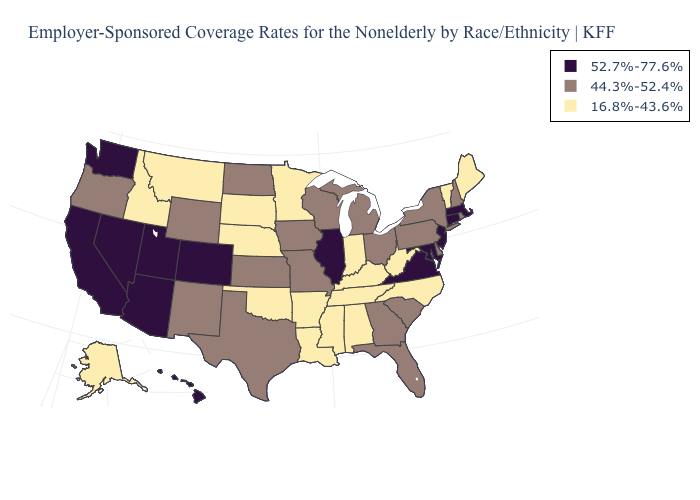What is the highest value in the West ?
Be succinct. 52.7%-77.6%. Does the map have missing data?
Answer briefly. No. What is the value of Iowa?
Answer briefly. 44.3%-52.4%. Among the states that border Iowa , does Nebraska have the lowest value?
Quick response, please. Yes. Among the states that border North Carolina , which have the lowest value?
Give a very brief answer. Tennessee. What is the value of North Carolina?
Keep it brief. 16.8%-43.6%. Does Illinois have the highest value in the USA?
Quick response, please. Yes. What is the value of Nevada?
Quick response, please. 52.7%-77.6%. Name the states that have a value in the range 44.3%-52.4%?
Write a very short answer. Delaware, Florida, Georgia, Iowa, Kansas, Michigan, Missouri, New Hampshire, New Mexico, New York, North Dakota, Ohio, Oregon, Pennsylvania, Rhode Island, South Carolina, Texas, Wisconsin, Wyoming. Name the states that have a value in the range 16.8%-43.6%?
Quick response, please. Alabama, Alaska, Arkansas, Idaho, Indiana, Kentucky, Louisiana, Maine, Minnesota, Mississippi, Montana, Nebraska, North Carolina, Oklahoma, South Dakota, Tennessee, Vermont, West Virginia. Which states have the lowest value in the USA?
Be succinct. Alabama, Alaska, Arkansas, Idaho, Indiana, Kentucky, Louisiana, Maine, Minnesota, Mississippi, Montana, Nebraska, North Carolina, Oklahoma, South Dakota, Tennessee, Vermont, West Virginia. What is the lowest value in the South?
Write a very short answer. 16.8%-43.6%. Name the states that have a value in the range 52.7%-77.6%?
Write a very short answer. Arizona, California, Colorado, Connecticut, Hawaii, Illinois, Maryland, Massachusetts, Nevada, New Jersey, Utah, Virginia, Washington. What is the value of Utah?
Give a very brief answer. 52.7%-77.6%. What is the lowest value in states that border Delaware?
Concise answer only. 44.3%-52.4%. 